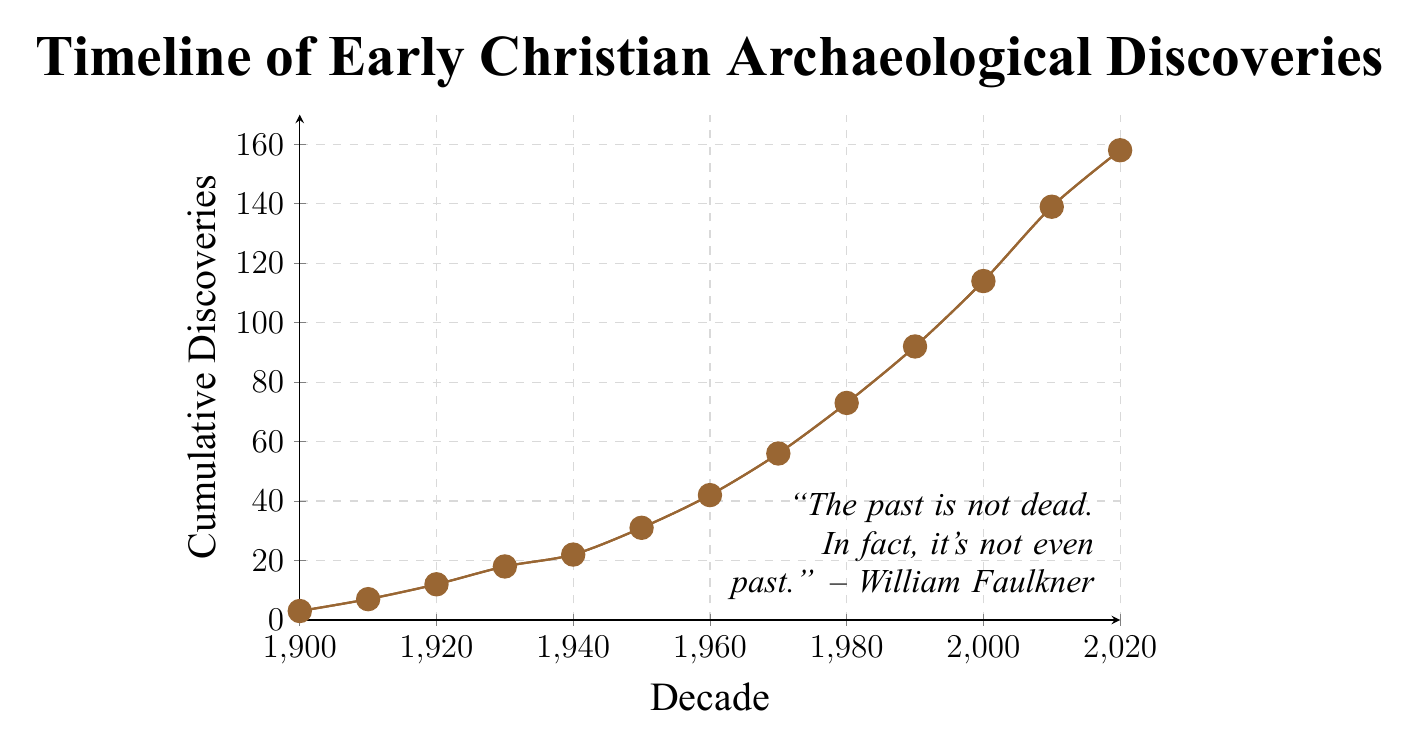What is the cumulative number of discoveries by 1960? The chart shows cumulative discoveries over the decades. The number of discoveries by 1960 is given directly by the y-axis value at the 1960 mark.
Answer: 42 Between which two decades is the biggest jump in cumulative discoveries observed? Observing the slope of the line, the largest increase appears between the 2000 and 2010 decades.
Answer: 2000 to 2010 What is the average number of cumulative discoveries per decade from 1900 to 1940? To find the average, sum the discoveries from 1900 to 1940 and then divide by the number of decades. (3 + 7 + 12 + 18 + 22) / 5 = 62 / 5
Answer: 12.4 In which decade does the chart first show more than 50 cumulative discoveries? By tracing the cumulative line, we see it crosses 50 between 1960 and 1970. The cumulative discoveries in 1970 are 56.
Answer: 1970 How many more cumulative discoveries were there in 2010 compared to 1980? Subtract the cumulative discoveries in 1980 from those in 2010. 139 - 73 = 66
Answer: 66 What is the rate of change in cumulative discoveries between 1950 and 1980? Calculate the change in discoveries and divide by the number of decades. (73 - 31) / (1980 - 1950) = 42 / 3 = 14 discoveries per decade.
Answer: 14 Which decade exhibited the slowest growth in cumulative discoveries? Comparing the slope of each segment, the 1900-1910 segment shows the smallest increase, from 3 to 7.
Answer: 1900 to 1910 What visual feature indicates the overall trend of the discoveries over time? The smooth, upward slope of the line from left to right indicates an increasing trend in cumulative discoveries.
Answer: Upward slope By how much did cumulative discoveries increase from 1990 to 2000? Subtract cumulative discoveries in 1990 from those in 2000. 114 - 92 = 22
Answer: 22 Observing the rate of increase, which decade saw the highest growth rate in discoveries relative to its preceding decade? Comparing the increases, 2010 shows the highest growth rate relative to 2000. (139 - 114) = 25 between 2000 and 2010.
Answer: 2010 